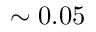Convert formula to latex. <formula><loc_0><loc_0><loc_500><loc_500>\sim 0 . 0 5</formula> 